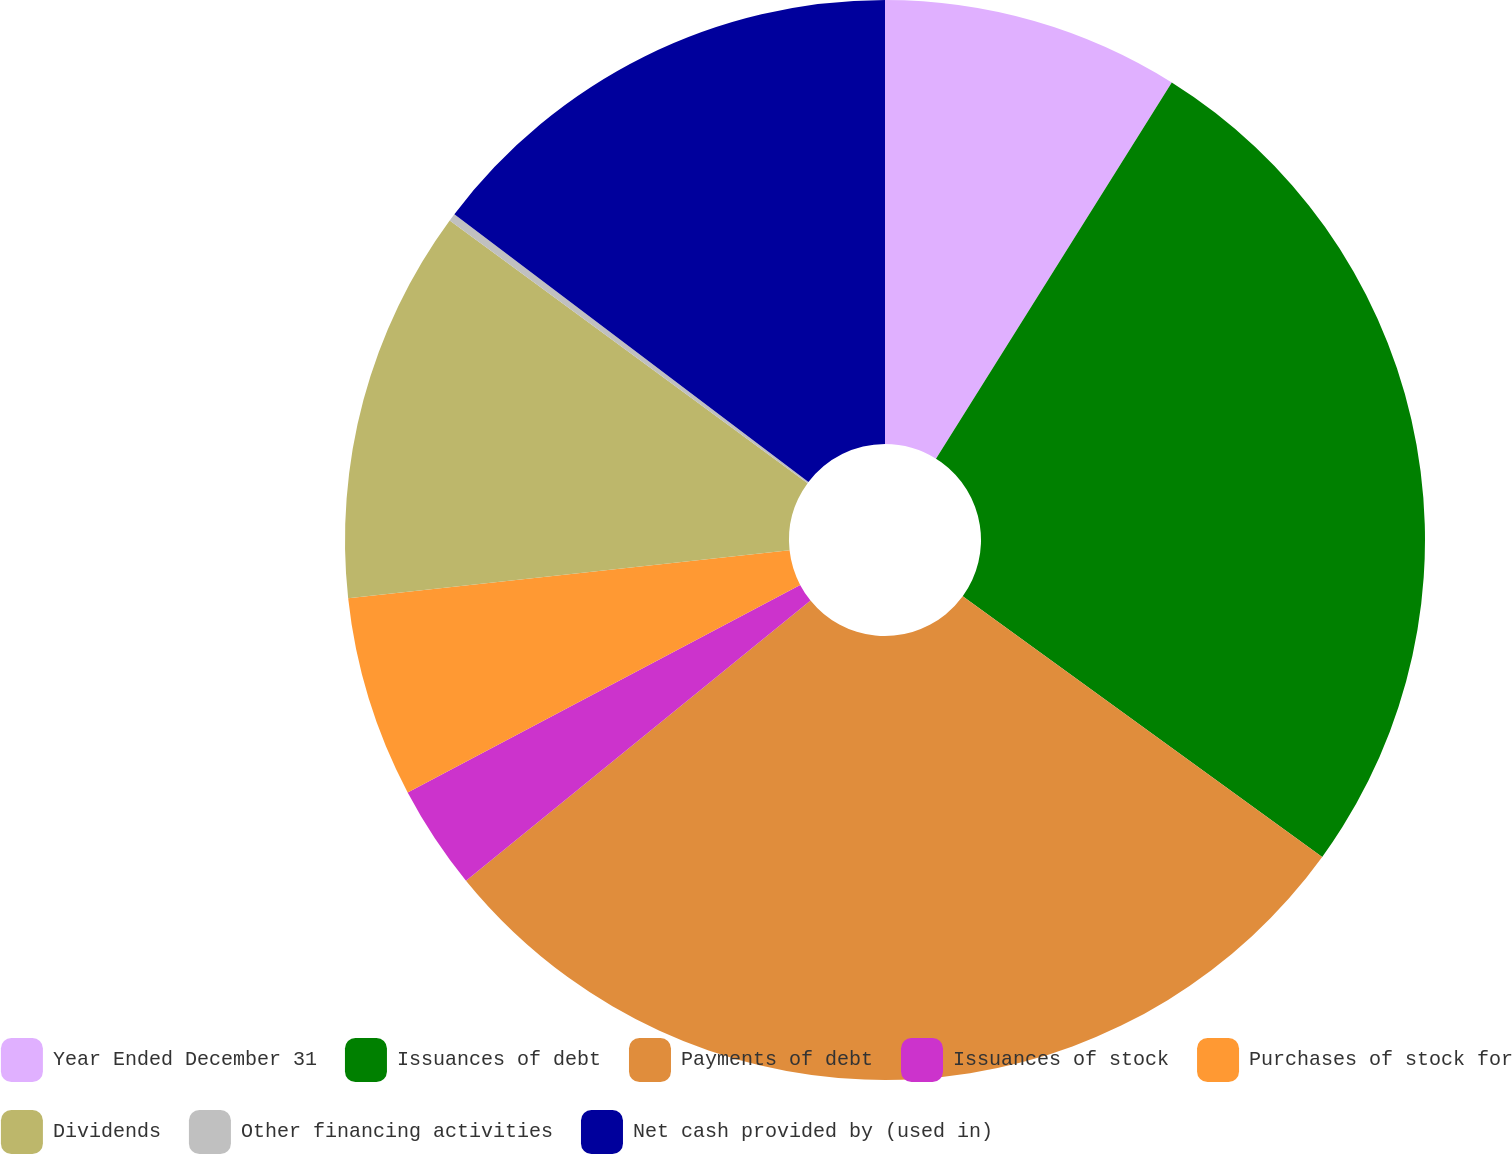<chart> <loc_0><loc_0><loc_500><loc_500><pie_chart><fcel>Year Ended December 31<fcel>Issuances of debt<fcel>Payments of debt<fcel>Issuances of stock<fcel>Purchases of stock for<fcel>Dividends<fcel>Other financing activities<fcel>Net cash provided by (used in)<nl><fcel>8.91%<fcel>26.07%<fcel>29.15%<fcel>3.12%<fcel>6.02%<fcel>11.8%<fcel>0.23%<fcel>14.69%<nl></chart> 